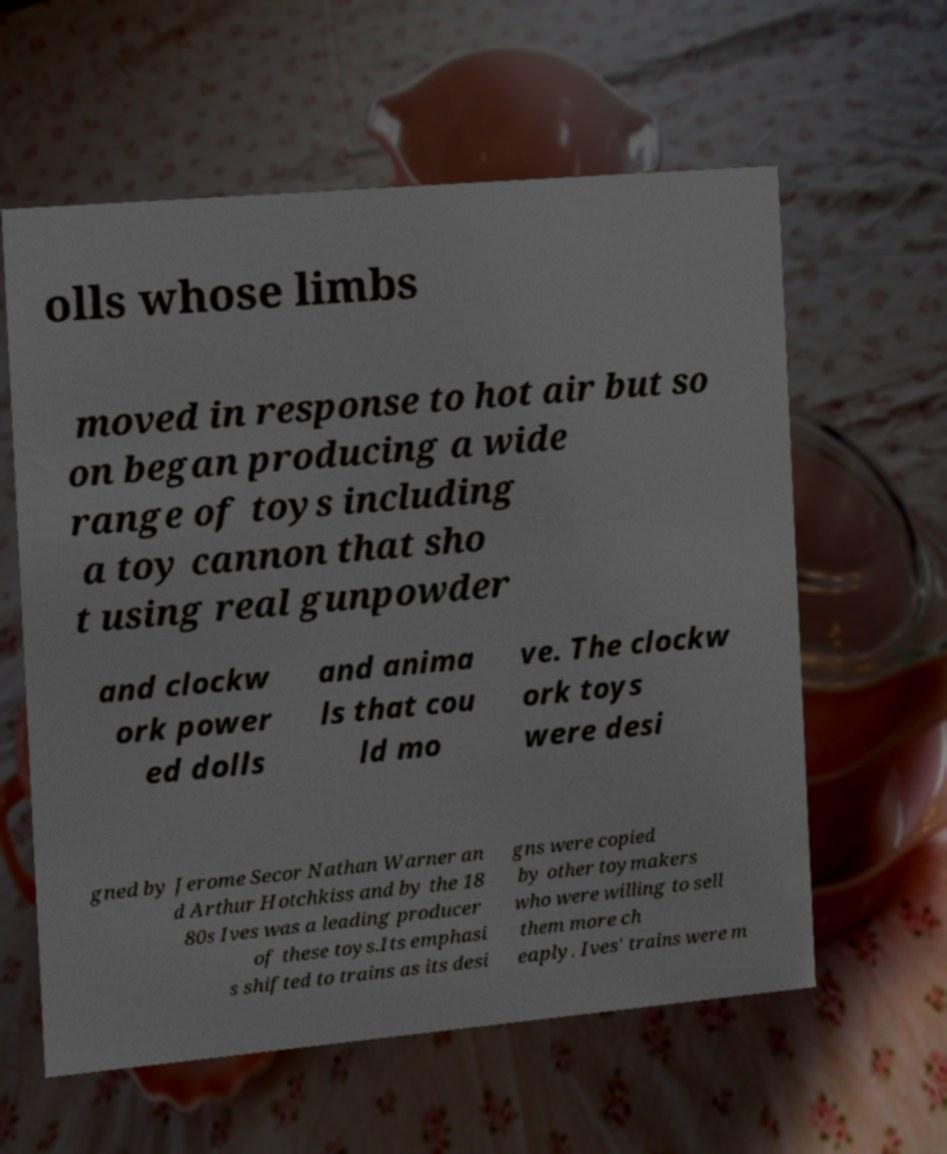For documentation purposes, I need the text within this image transcribed. Could you provide that? olls whose limbs moved in response to hot air but so on began producing a wide range of toys including a toy cannon that sho t using real gunpowder and clockw ork power ed dolls and anima ls that cou ld mo ve. The clockw ork toys were desi gned by Jerome Secor Nathan Warner an d Arthur Hotchkiss and by the 18 80s Ives was a leading producer of these toys.Its emphasi s shifted to trains as its desi gns were copied by other toymakers who were willing to sell them more ch eaply. Ives' trains were m 